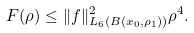<formula> <loc_0><loc_0><loc_500><loc_500>F ( \rho ) \leq \| f \| _ { L _ { 6 } ( B ( x _ { 0 } , \rho _ { 1 } ) ) } ^ { 2 } \rho ^ { 4 } .</formula> 